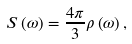<formula> <loc_0><loc_0><loc_500><loc_500>S \left ( \omega \right ) = \frac { 4 \pi } { 3 } \rho \left ( \omega \right ) ,</formula> 